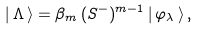Convert formula to latex. <formula><loc_0><loc_0><loc_500><loc_500>| \, { \Lambda } \, \rangle = \beta _ { m } \, ( S ^ { - } ) ^ { m - 1 } \, | \, \varphi _ { \lambda } \, \rangle \, ,</formula> 